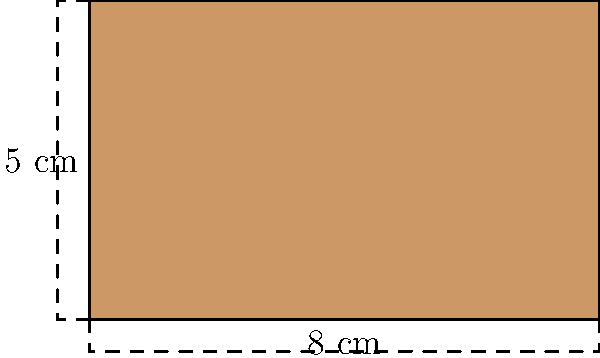You are preparing a rectangular clay tablet for a pottery decoration lesson with your 8-year-old student. The tablet measures 8 cm in width and 5 cm in height. What is the total area of the clay tablet that can be used for decoration? To find the area of the rectangular clay tablet, we need to follow these steps:

1. Identify the formula for the area of a rectangle:
   Area = length × width

2. Identify the dimensions of the clay tablet:
   Width = 8 cm
   Height (length) = 5 cm

3. Apply the formula using the given dimensions:
   Area = 5 cm × 8 cm

4. Multiply the numbers:
   Area = 40 cm²

Therefore, the total area of the clay tablet that can be used for decoration is 40 square centimeters.
Answer: 40 cm² 